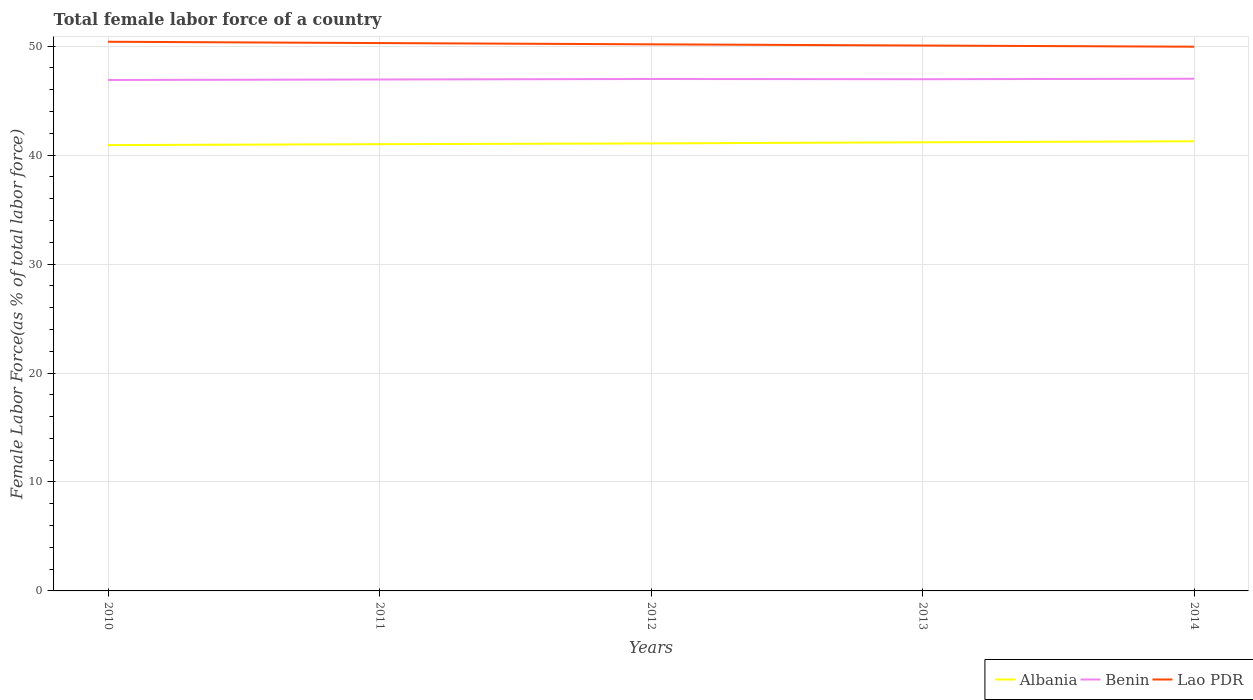How many different coloured lines are there?
Ensure brevity in your answer.  3. Does the line corresponding to Lao PDR intersect with the line corresponding to Benin?
Ensure brevity in your answer.  No. Across all years, what is the maximum percentage of female labor force in Lao PDR?
Offer a terse response. 49.95. In which year was the percentage of female labor force in Benin maximum?
Your response must be concise. 2010. What is the total percentage of female labor force in Lao PDR in the graph?
Your answer should be very brief. 0.11. What is the difference between the highest and the second highest percentage of female labor force in Lao PDR?
Your answer should be compact. 0.45. What is the difference between the highest and the lowest percentage of female labor force in Albania?
Your answer should be compact. 2. How many lines are there?
Your response must be concise. 3. What is the difference between two consecutive major ticks on the Y-axis?
Keep it short and to the point. 10. Are the values on the major ticks of Y-axis written in scientific E-notation?
Make the answer very short. No. Does the graph contain any zero values?
Make the answer very short. No. How many legend labels are there?
Make the answer very short. 3. What is the title of the graph?
Make the answer very short. Total female labor force of a country. What is the label or title of the Y-axis?
Offer a very short reply. Female Labor Force(as % of total labor force). What is the Female Labor Force(as % of total labor force) in Albania in 2010?
Provide a succinct answer. 40.92. What is the Female Labor Force(as % of total labor force) in Benin in 2010?
Your response must be concise. 46.89. What is the Female Labor Force(as % of total labor force) in Lao PDR in 2010?
Provide a short and direct response. 50.4. What is the Female Labor Force(as % of total labor force) of Albania in 2011?
Provide a succinct answer. 41. What is the Female Labor Force(as % of total labor force) of Benin in 2011?
Make the answer very short. 46.94. What is the Female Labor Force(as % of total labor force) in Lao PDR in 2011?
Make the answer very short. 50.28. What is the Female Labor Force(as % of total labor force) of Albania in 2012?
Offer a very short reply. 41.07. What is the Female Labor Force(as % of total labor force) of Benin in 2012?
Offer a very short reply. 46.98. What is the Female Labor Force(as % of total labor force) in Lao PDR in 2012?
Provide a short and direct response. 50.17. What is the Female Labor Force(as % of total labor force) of Albania in 2013?
Keep it short and to the point. 41.18. What is the Female Labor Force(as % of total labor force) of Benin in 2013?
Ensure brevity in your answer.  46.96. What is the Female Labor Force(as % of total labor force) in Lao PDR in 2013?
Offer a terse response. 50.05. What is the Female Labor Force(as % of total labor force) in Albania in 2014?
Offer a very short reply. 41.27. What is the Female Labor Force(as % of total labor force) of Benin in 2014?
Your answer should be very brief. 47.01. What is the Female Labor Force(as % of total labor force) in Lao PDR in 2014?
Your response must be concise. 49.95. Across all years, what is the maximum Female Labor Force(as % of total labor force) in Albania?
Offer a terse response. 41.27. Across all years, what is the maximum Female Labor Force(as % of total labor force) in Benin?
Make the answer very short. 47.01. Across all years, what is the maximum Female Labor Force(as % of total labor force) of Lao PDR?
Offer a very short reply. 50.4. Across all years, what is the minimum Female Labor Force(as % of total labor force) of Albania?
Your response must be concise. 40.92. Across all years, what is the minimum Female Labor Force(as % of total labor force) of Benin?
Offer a very short reply. 46.89. Across all years, what is the minimum Female Labor Force(as % of total labor force) in Lao PDR?
Give a very brief answer. 49.95. What is the total Female Labor Force(as % of total labor force) of Albania in the graph?
Offer a very short reply. 205.43. What is the total Female Labor Force(as % of total labor force) of Benin in the graph?
Provide a short and direct response. 234.79. What is the total Female Labor Force(as % of total labor force) of Lao PDR in the graph?
Ensure brevity in your answer.  250.85. What is the difference between the Female Labor Force(as % of total labor force) in Albania in 2010 and that in 2011?
Your response must be concise. -0.08. What is the difference between the Female Labor Force(as % of total labor force) of Benin in 2010 and that in 2011?
Your answer should be very brief. -0.04. What is the difference between the Female Labor Force(as % of total labor force) in Lao PDR in 2010 and that in 2011?
Your answer should be compact. 0.12. What is the difference between the Female Labor Force(as % of total labor force) in Albania in 2010 and that in 2012?
Provide a succinct answer. -0.16. What is the difference between the Female Labor Force(as % of total labor force) of Benin in 2010 and that in 2012?
Offer a very short reply. -0.09. What is the difference between the Female Labor Force(as % of total labor force) of Lao PDR in 2010 and that in 2012?
Make the answer very short. 0.24. What is the difference between the Female Labor Force(as % of total labor force) of Albania in 2010 and that in 2013?
Your answer should be very brief. -0.26. What is the difference between the Female Labor Force(as % of total labor force) in Benin in 2010 and that in 2013?
Ensure brevity in your answer.  -0.07. What is the difference between the Female Labor Force(as % of total labor force) in Lao PDR in 2010 and that in 2013?
Offer a very short reply. 0.35. What is the difference between the Female Labor Force(as % of total labor force) in Albania in 2010 and that in 2014?
Provide a succinct answer. -0.35. What is the difference between the Female Labor Force(as % of total labor force) in Benin in 2010 and that in 2014?
Keep it short and to the point. -0.11. What is the difference between the Female Labor Force(as % of total labor force) in Lao PDR in 2010 and that in 2014?
Your response must be concise. 0.45. What is the difference between the Female Labor Force(as % of total labor force) of Albania in 2011 and that in 2012?
Offer a very short reply. -0.07. What is the difference between the Female Labor Force(as % of total labor force) in Benin in 2011 and that in 2012?
Your answer should be very brief. -0.04. What is the difference between the Female Labor Force(as % of total labor force) in Lao PDR in 2011 and that in 2012?
Your answer should be compact. 0.12. What is the difference between the Female Labor Force(as % of total labor force) of Albania in 2011 and that in 2013?
Keep it short and to the point. -0.18. What is the difference between the Female Labor Force(as % of total labor force) in Benin in 2011 and that in 2013?
Your response must be concise. -0.03. What is the difference between the Female Labor Force(as % of total labor force) in Lao PDR in 2011 and that in 2013?
Your answer should be compact. 0.23. What is the difference between the Female Labor Force(as % of total labor force) in Albania in 2011 and that in 2014?
Make the answer very short. -0.27. What is the difference between the Female Labor Force(as % of total labor force) in Benin in 2011 and that in 2014?
Offer a very short reply. -0.07. What is the difference between the Female Labor Force(as % of total labor force) in Lao PDR in 2011 and that in 2014?
Make the answer very short. 0.33. What is the difference between the Female Labor Force(as % of total labor force) of Albania in 2012 and that in 2013?
Your answer should be compact. -0.1. What is the difference between the Female Labor Force(as % of total labor force) of Benin in 2012 and that in 2013?
Your answer should be compact. 0.02. What is the difference between the Female Labor Force(as % of total labor force) of Lao PDR in 2012 and that in 2013?
Your answer should be very brief. 0.11. What is the difference between the Female Labor Force(as % of total labor force) of Albania in 2012 and that in 2014?
Keep it short and to the point. -0.19. What is the difference between the Female Labor Force(as % of total labor force) in Benin in 2012 and that in 2014?
Give a very brief answer. -0.03. What is the difference between the Female Labor Force(as % of total labor force) of Lao PDR in 2012 and that in 2014?
Ensure brevity in your answer.  0.22. What is the difference between the Female Labor Force(as % of total labor force) of Albania in 2013 and that in 2014?
Your answer should be compact. -0.09. What is the difference between the Female Labor Force(as % of total labor force) in Benin in 2013 and that in 2014?
Give a very brief answer. -0.04. What is the difference between the Female Labor Force(as % of total labor force) of Lao PDR in 2013 and that in 2014?
Your response must be concise. 0.11. What is the difference between the Female Labor Force(as % of total labor force) of Albania in 2010 and the Female Labor Force(as % of total labor force) of Benin in 2011?
Offer a very short reply. -6.02. What is the difference between the Female Labor Force(as % of total labor force) in Albania in 2010 and the Female Labor Force(as % of total labor force) in Lao PDR in 2011?
Offer a terse response. -9.36. What is the difference between the Female Labor Force(as % of total labor force) in Benin in 2010 and the Female Labor Force(as % of total labor force) in Lao PDR in 2011?
Keep it short and to the point. -3.39. What is the difference between the Female Labor Force(as % of total labor force) in Albania in 2010 and the Female Labor Force(as % of total labor force) in Benin in 2012?
Keep it short and to the point. -6.07. What is the difference between the Female Labor Force(as % of total labor force) of Albania in 2010 and the Female Labor Force(as % of total labor force) of Lao PDR in 2012?
Ensure brevity in your answer.  -9.25. What is the difference between the Female Labor Force(as % of total labor force) in Benin in 2010 and the Female Labor Force(as % of total labor force) in Lao PDR in 2012?
Your response must be concise. -3.27. What is the difference between the Female Labor Force(as % of total labor force) of Albania in 2010 and the Female Labor Force(as % of total labor force) of Benin in 2013?
Your response must be concise. -6.05. What is the difference between the Female Labor Force(as % of total labor force) in Albania in 2010 and the Female Labor Force(as % of total labor force) in Lao PDR in 2013?
Give a very brief answer. -9.14. What is the difference between the Female Labor Force(as % of total labor force) in Benin in 2010 and the Female Labor Force(as % of total labor force) in Lao PDR in 2013?
Provide a succinct answer. -3.16. What is the difference between the Female Labor Force(as % of total labor force) of Albania in 2010 and the Female Labor Force(as % of total labor force) of Benin in 2014?
Your answer should be compact. -6.09. What is the difference between the Female Labor Force(as % of total labor force) of Albania in 2010 and the Female Labor Force(as % of total labor force) of Lao PDR in 2014?
Your answer should be very brief. -9.03. What is the difference between the Female Labor Force(as % of total labor force) of Benin in 2010 and the Female Labor Force(as % of total labor force) of Lao PDR in 2014?
Provide a succinct answer. -3.05. What is the difference between the Female Labor Force(as % of total labor force) in Albania in 2011 and the Female Labor Force(as % of total labor force) in Benin in 2012?
Ensure brevity in your answer.  -5.98. What is the difference between the Female Labor Force(as % of total labor force) in Albania in 2011 and the Female Labor Force(as % of total labor force) in Lao PDR in 2012?
Offer a very short reply. -9.17. What is the difference between the Female Labor Force(as % of total labor force) in Benin in 2011 and the Female Labor Force(as % of total labor force) in Lao PDR in 2012?
Make the answer very short. -3.23. What is the difference between the Female Labor Force(as % of total labor force) in Albania in 2011 and the Female Labor Force(as % of total labor force) in Benin in 2013?
Offer a very short reply. -5.96. What is the difference between the Female Labor Force(as % of total labor force) in Albania in 2011 and the Female Labor Force(as % of total labor force) in Lao PDR in 2013?
Offer a terse response. -9.06. What is the difference between the Female Labor Force(as % of total labor force) in Benin in 2011 and the Female Labor Force(as % of total labor force) in Lao PDR in 2013?
Give a very brief answer. -3.12. What is the difference between the Female Labor Force(as % of total labor force) of Albania in 2011 and the Female Labor Force(as % of total labor force) of Benin in 2014?
Give a very brief answer. -6.01. What is the difference between the Female Labor Force(as % of total labor force) in Albania in 2011 and the Female Labor Force(as % of total labor force) in Lao PDR in 2014?
Provide a short and direct response. -8.95. What is the difference between the Female Labor Force(as % of total labor force) in Benin in 2011 and the Female Labor Force(as % of total labor force) in Lao PDR in 2014?
Provide a succinct answer. -3.01. What is the difference between the Female Labor Force(as % of total labor force) of Albania in 2012 and the Female Labor Force(as % of total labor force) of Benin in 2013?
Make the answer very short. -5.89. What is the difference between the Female Labor Force(as % of total labor force) in Albania in 2012 and the Female Labor Force(as % of total labor force) in Lao PDR in 2013?
Ensure brevity in your answer.  -8.98. What is the difference between the Female Labor Force(as % of total labor force) in Benin in 2012 and the Female Labor Force(as % of total labor force) in Lao PDR in 2013?
Provide a short and direct response. -3.07. What is the difference between the Female Labor Force(as % of total labor force) in Albania in 2012 and the Female Labor Force(as % of total labor force) in Benin in 2014?
Offer a very short reply. -5.94. What is the difference between the Female Labor Force(as % of total labor force) of Albania in 2012 and the Female Labor Force(as % of total labor force) of Lao PDR in 2014?
Your answer should be very brief. -8.88. What is the difference between the Female Labor Force(as % of total labor force) in Benin in 2012 and the Female Labor Force(as % of total labor force) in Lao PDR in 2014?
Offer a very short reply. -2.97. What is the difference between the Female Labor Force(as % of total labor force) in Albania in 2013 and the Female Labor Force(as % of total labor force) in Benin in 2014?
Give a very brief answer. -5.83. What is the difference between the Female Labor Force(as % of total labor force) of Albania in 2013 and the Female Labor Force(as % of total labor force) of Lao PDR in 2014?
Make the answer very short. -8.77. What is the difference between the Female Labor Force(as % of total labor force) of Benin in 2013 and the Female Labor Force(as % of total labor force) of Lao PDR in 2014?
Provide a short and direct response. -2.98. What is the average Female Labor Force(as % of total labor force) of Albania per year?
Make the answer very short. 41.09. What is the average Female Labor Force(as % of total labor force) of Benin per year?
Provide a succinct answer. 46.96. What is the average Female Labor Force(as % of total labor force) in Lao PDR per year?
Provide a succinct answer. 50.17. In the year 2010, what is the difference between the Female Labor Force(as % of total labor force) of Albania and Female Labor Force(as % of total labor force) of Benin?
Provide a succinct answer. -5.98. In the year 2010, what is the difference between the Female Labor Force(as % of total labor force) of Albania and Female Labor Force(as % of total labor force) of Lao PDR?
Offer a very short reply. -9.49. In the year 2010, what is the difference between the Female Labor Force(as % of total labor force) of Benin and Female Labor Force(as % of total labor force) of Lao PDR?
Make the answer very short. -3.51. In the year 2011, what is the difference between the Female Labor Force(as % of total labor force) in Albania and Female Labor Force(as % of total labor force) in Benin?
Provide a short and direct response. -5.94. In the year 2011, what is the difference between the Female Labor Force(as % of total labor force) in Albania and Female Labor Force(as % of total labor force) in Lao PDR?
Provide a short and direct response. -9.28. In the year 2011, what is the difference between the Female Labor Force(as % of total labor force) of Benin and Female Labor Force(as % of total labor force) of Lao PDR?
Your response must be concise. -3.34. In the year 2012, what is the difference between the Female Labor Force(as % of total labor force) in Albania and Female Labor Force(as % of total labor force) in Benin?
Provide a succinct answer. -5.91. In the year 2012, what is the difference between the Female Labor Force(as % of total labor force) of Albania and Female Labor Force(as % of total labor force) of Lao PDR?
Provide a short and direct response. -9.09. In the year 2012, what is the difference between the Female Labor Force(as % of total labor force) in Benin and Female Labor Force(as % of total labor force) in Lao PDR?
Offer a very short reply. -3.18. In the year 2013, what is the difference between the Female Labor Force(as % of total labor force) of Albania and Female Labor Force(as % of total labor force) of Benin?
Make the answer very short. -5.79. In the year 2013, what is the difference between the Female Labor Force(as % of total labor force) of Albania and Female Labor Force(as % of total labor force) of Lao PDR?
Keep it short and to the point. -8.88. In the year 2013, what is the difference between the Female Labor Force(as % of total labor force) in Benin and Female Labor Force(as % of total labor force) in Lao PDR?
Provide a short and direct response. -3.09. In the year 2014, what is the difference between the Female Labor Force(as % of total labor force) in Albania and Female Labor Force(as % of total labor force) in Benin?
Ensure brevity in your answer.  -5.74. In the year 2014, what is the difference between the Female Labor Force(as % of total labor force) in Albania and Female Labor Force(as % of total labor force) in Lao PDR?
Provide a short and direct response. -8.68. In the year 2014, what is the difference between the Female Labor Force(as % of total labor force) of Benin and Female Labor Force(as % of total labor force) of Lao PDR?
Offer a terse response. -2.94. What is the ratio of the Female Labor Force(as % of total labor force) of Lao PDR in 2010 to that in 2011?
Your response must be concise. 1. What is the ratio of the Female Labor Force(as % of total labor force) in Benin in 2010 to that in 2012?
Your response must be concise. 1. What is the ratio of the Female Labor Force(as % of total labor force) of Benin in 2010 to that in 2014?
Offer a very short reply. 1. What is the ratio of the Female Labor Force(as % of total labor force) in Lao PDR in 2010 to that in 2014?
Your answer should be compact. 1.01. What is the ratio of the Female Labor Force(as % of total labor force) in Albania in 2011 to that in 2012?
Your answer should be very brief. 1. What is the ratio of the Female Labor Force(as % of total labor force) of Benin in 2011 to that in 2012?
Offer a very short reply. 1. What is the ratio of the Female Labor Force(as % of total labor force) of Lao PDR in 2011 to that in 2013?
Keep it short and to the point. 1. What is the ratio of the Female Labor Force(as % of total labor force) of Benin in 2011 to that in 2014?
Ensure brevity in your answer.  1. What is the ratio of the Female Labor Force(as % of total labor force) in Albania in 2012 to that in 2013?
Ensure brevity in your answer.  1. What is the ratio of the Female Labor Force(as % of total labor force) in Benin in 2012 to that in 2013?
Make the answer very short. 1. What is the ratio of the Female Labor Force(as % of total labor force) of Benin in 2012 to that in 2014?
Your answer should be compact. 1. What is the ratio of the Female Labor Force(as % of total labor force) in Benin in 2013 to that in 2014?
Keep it short and to the point. 1. What is the ratio of the Female Labor Force(as % of total labor force) of Lao PDR in 2013 to that in 2014?
Your response must be concise. 1. What is the difference between the highest and the second highest Female Labor Force(as % of total labor force) of Albania?
Provide a succinct answer. 0.09. What is the difference between the highest and the second highest Female Labor Force(as % of total labor force) in Benin?
Your answer should be compact. 0.03. What is the difference between the highest and the second highest Female Labor Force(as % of total labor force) in Lao PDR?
Make the answer very short. 0.12. What is the difference between the highest and the lowest Female Labor Force(as % of total labor force) in Albania?
Provide a short and direct response. 0.35. What is the difference between the highest and the lowest Female Labor Force(as % of total labor force) of Benin?
Keep it short and to the point. 0.11. What is the difference between the highest and the lowest Female Labor Force(as % of total labor force) in Lao PDR?
Offer a terse response. 0.45. 